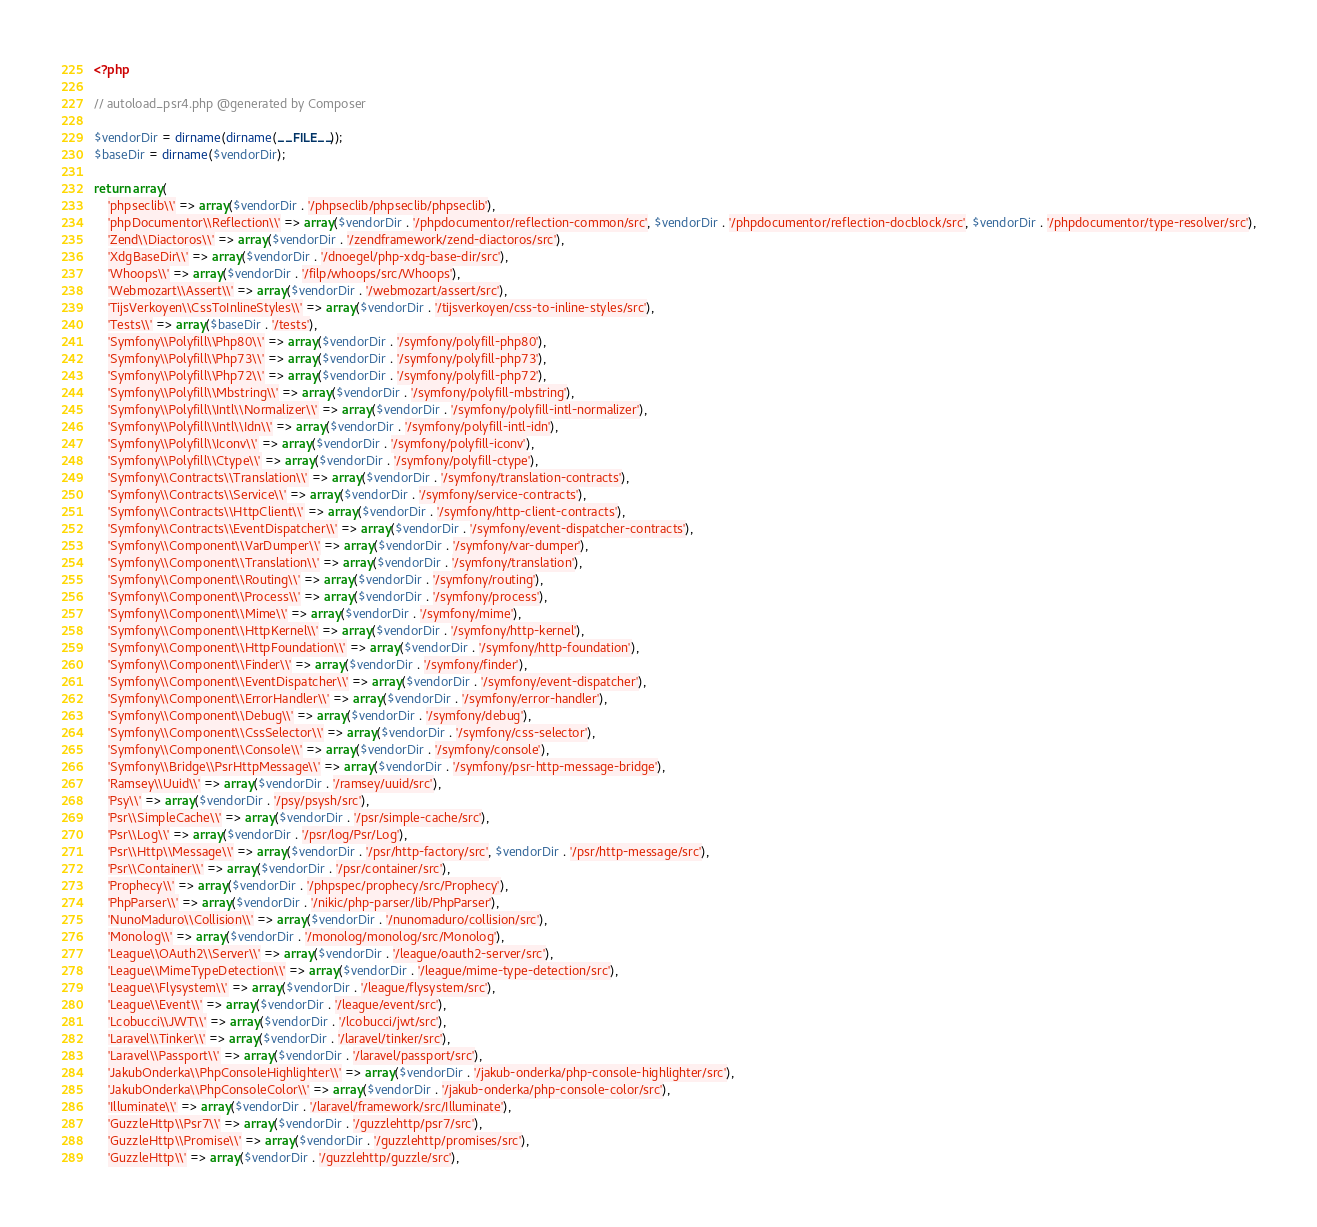<code> <loc_0><loc_0><loc_500><loc_500><_PHP_><?php

// autoload_psr4.php @generated by Composer

$vendorDir = dirname(dirname(__FILE__));
$baseDir = dirname($vendorDir);

return array(
    'phpseclib\\' => array($vendorDir . '/phpseclib/phpseclib/phpseclib'),
    'phpDocumentor\\Reflection\\' => array($vendorDir . '/phpdocumentor/reflection-common/src', $vendorDir . '/phpdocumentor/reflection-docblock/src', $vendorDir . '/phpdocumentor/type-resolver/src'),
    'Zend\\Diactoros\\' => array($vendorDir . '/zendframework/zend-diactoros/src'),
    'XdgBaseDir\\' => array($vendorDir . '/dnoegel/php-xdg-base-dir/src'),
    'Whoops\\' => array($vendorDir . '/filp/whoops/src/Whoops'),
    'Webmozart\\Assert\\' => array($vendorDir . '/webmozart/assert/src'),
    'TijsVerkoyen\\CssToInlineStyles\\' => array($vendorDir . '/tijsverkoyen/css-to-inline-styles/src'),
    'Tests\\' => array($baseDir . '/tests'),
    'Symfony\\Polyfill\\Php80\\' => array($vendorDir . '/symfony/polyfill-php80'),
    'Symfony\\Polyfill\\Php73\\' => array($vendorDir . '/symfony/polyfill-php73'),
    'Symfony\\Polyfill\\Php72\\' => array($vendorDir . '/symfony/polyfill-php72'),
    'Symfony\\Polyfill\\Mbstring\\' => array($vendorDir . '/symfony/polyfill-mbstring'),
    'Symfony\\Polyfill\\Intl\\Normalizer\\' => array($vendorDir . '/symfony/polyfill-intl-normalizer'),
    'Symfony\\Polyfill\\Intl\\Idn\\' => array($vendorDir . '/symfony/polyfill-intl-idn'),
    'Symfony\\Polyfill\\Iconv\\' => array($vendorDir . '/symfony/polyfill-iconv'),
    'Symfony\\Polyfill\\Ctype\\' => array($vendorDir . '/symfony/polyfill-ctype'),
    'Symfony\\Contracts\\Translation\\' => array($vendorDir . '/symfony/translation-contracts'),
    'Symfony\\Contracts\\Service\\' => array($vendorDir . '/symfony/service-contracts'),
    'Symfony\\Contracts\\HttpClient\\' => array($vendorDir . '/symfony/http-client-contracts'),
    'Symfony\\Contracts\\EventDispatcher\\' => array($vendorDir . '/symfony/event-dispatcher-contracts'),
    'Symfony\\Component\\VarDumper\\' => array($vendorDir . '/symfony/var-dumper'),
    'Symfony\\Component\\Translation\\' => array($vendorDir . '/symfony/translation'),
    'Symfony\\Component\\Routing\\' => array($vendorDir . '/symfony/routing'),
    'Symfony\\Component\\Process\\' => array($vendorDir . '/symfony/process'),
    'Symfony\\Component\\Mime\\' => array($vendorDir . '/symfony/mime'),
    'Symfony\\Component\\HttpKernel\\' => array($vendorDir . '/symfony/http-kernel'),
    'Symfony\\Component\\HttpFoundation\\' => array($vendorDir . '/symfony/http-foundation'),
    'Symfony\\Component\\Finder\\' => array($vendorDir . '/symfony/finder'),
    'Symfony\\Component\\EventDispatcher\\' => array($vendorDir . '/symfony/event-dispatcher'),
    'Symfony\\Component\\ErrorHandler\\' => array($vendorDir . '/symfony/error-handler'),
    'Symfony\\Component\\Debug\\' => array($vendorDir . '/symfony/debug'),
    'Symfony\\Component\\CssSelector\\' => array($vendorDir . '/symfony/css-selector'),
    'Symfony\\Component\\Console\\' => array($vendorDir . '/symfony/console'),
    'Symfony\\Bridge\\PsrHttpMessage\\' => array($vendorDir . '/symfony/psr-http-message-bridge'),
    'Ramsey\\Uuid\\' => array($vendorDir . '/ramsey/uuid/src'),
    'Psy\\' => array($vendorDir . '/psy/psysh/src'),
    'Psr\\SimpleCache\\' => array($vendorDir . '/psr/simple-cache/src'),
    'Psr\\Log\\' => array($vendorDir . '/psr/log/Psr/Log'),
    'Psr\\Http\\Message\\' => array($vendorDir . '/psr/http-factory/src', $vendorDir . '/psr/http-message/src'),
    'Psr\\Container\\' => array($vendorDir . '/psr/container/src'),
    'Prophecy\\' => array($vendorDir . '/phpspec/prophecy/src/Prophecy'),
    'PhpParser\\' => array($vendorDir . '/nikic/php-parser/lib/PhpParser'),
    'NunoMaduro\\Collision\\' => array($vendorDir . '/nunomaduro/collision/src'),
    'Monolog\\' => array($vendorDir . '/monolog/monolog/src/Monolog'),
    'League\\OAuth2\\Server\\' => array($vendorDir . '/league/oauth2-server/src'),
    'League\\MimeTypeDetection\\' => array($vendorDir . '/league/mime-type-detection/src'),
    'League\\Flysystem\\' => array($vendorDir . '/league/flysystem/src'),
    'League\\Event\\' => array($vendorDir . '/league/event/src'),
    'Lcobucci\\JWT\\' => array($vendorDir . '/lcobucci/jwt/src'),
    'Laravel\\Tinker\\' => array($vendorDir . '/laravel/tinker/src'),
    'Laravel\\Passport\\' => array($vendorDir . '/laravel/passport/src'),
    'JakubOnderka\\PhpConsoleHighlighter\\' => array($vendorDir . '/jakub-onderka/php-console-highlighter/src'),
    'JakubOnderka\\PhpConsoleColor\\' => array($vendorDir . '/jakub-onderka/php-console-color/src'),
    'Illuminate\\' => array($vendorDir . '/laravel/framework/src/Illuminate'),
    'GuzzleHttp\\Psr7\\' => array($vendorDir . '/guzzlehttp/psr7/src'),
    'GuzzleHttp\\Promise\\' => array($vendorDir . '/guzzlehttp/promises/src'),
    'GuzzleHttp\\' => array($vendorDir . '/guzzlehttp/guzzle/src'),</code> 